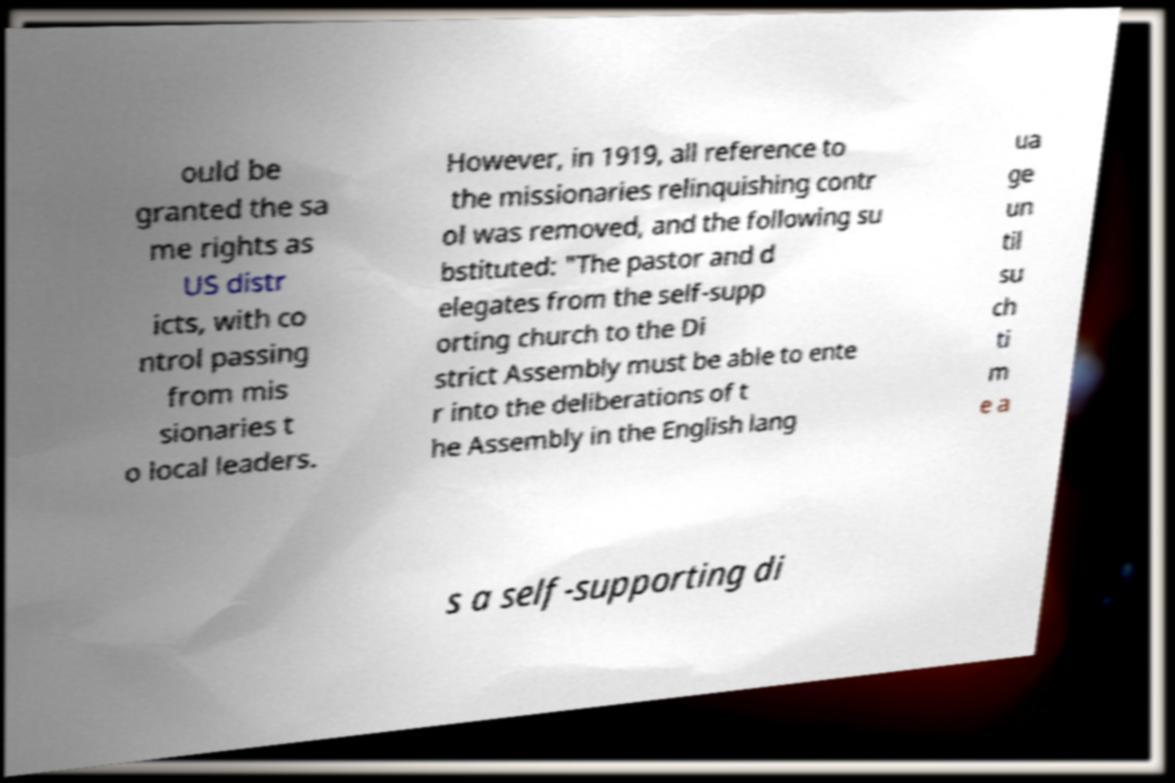I need the written content from this picture converted into text. Can you do that? ould be granted the sa me rights as US distr icts, with co ntrol passing from mis sionaries t o local leaders. However, in 1919, all reference to the missionaries relinquishing contr ol was removed, and the following su bstituted: "The pastor and d elegates from the self-supp orting church to the Di strict Assembly must be able to ente r into the deliberations of t he Assembly in the English lang ua ge un til su ch ti m e a s a self-supporting di 